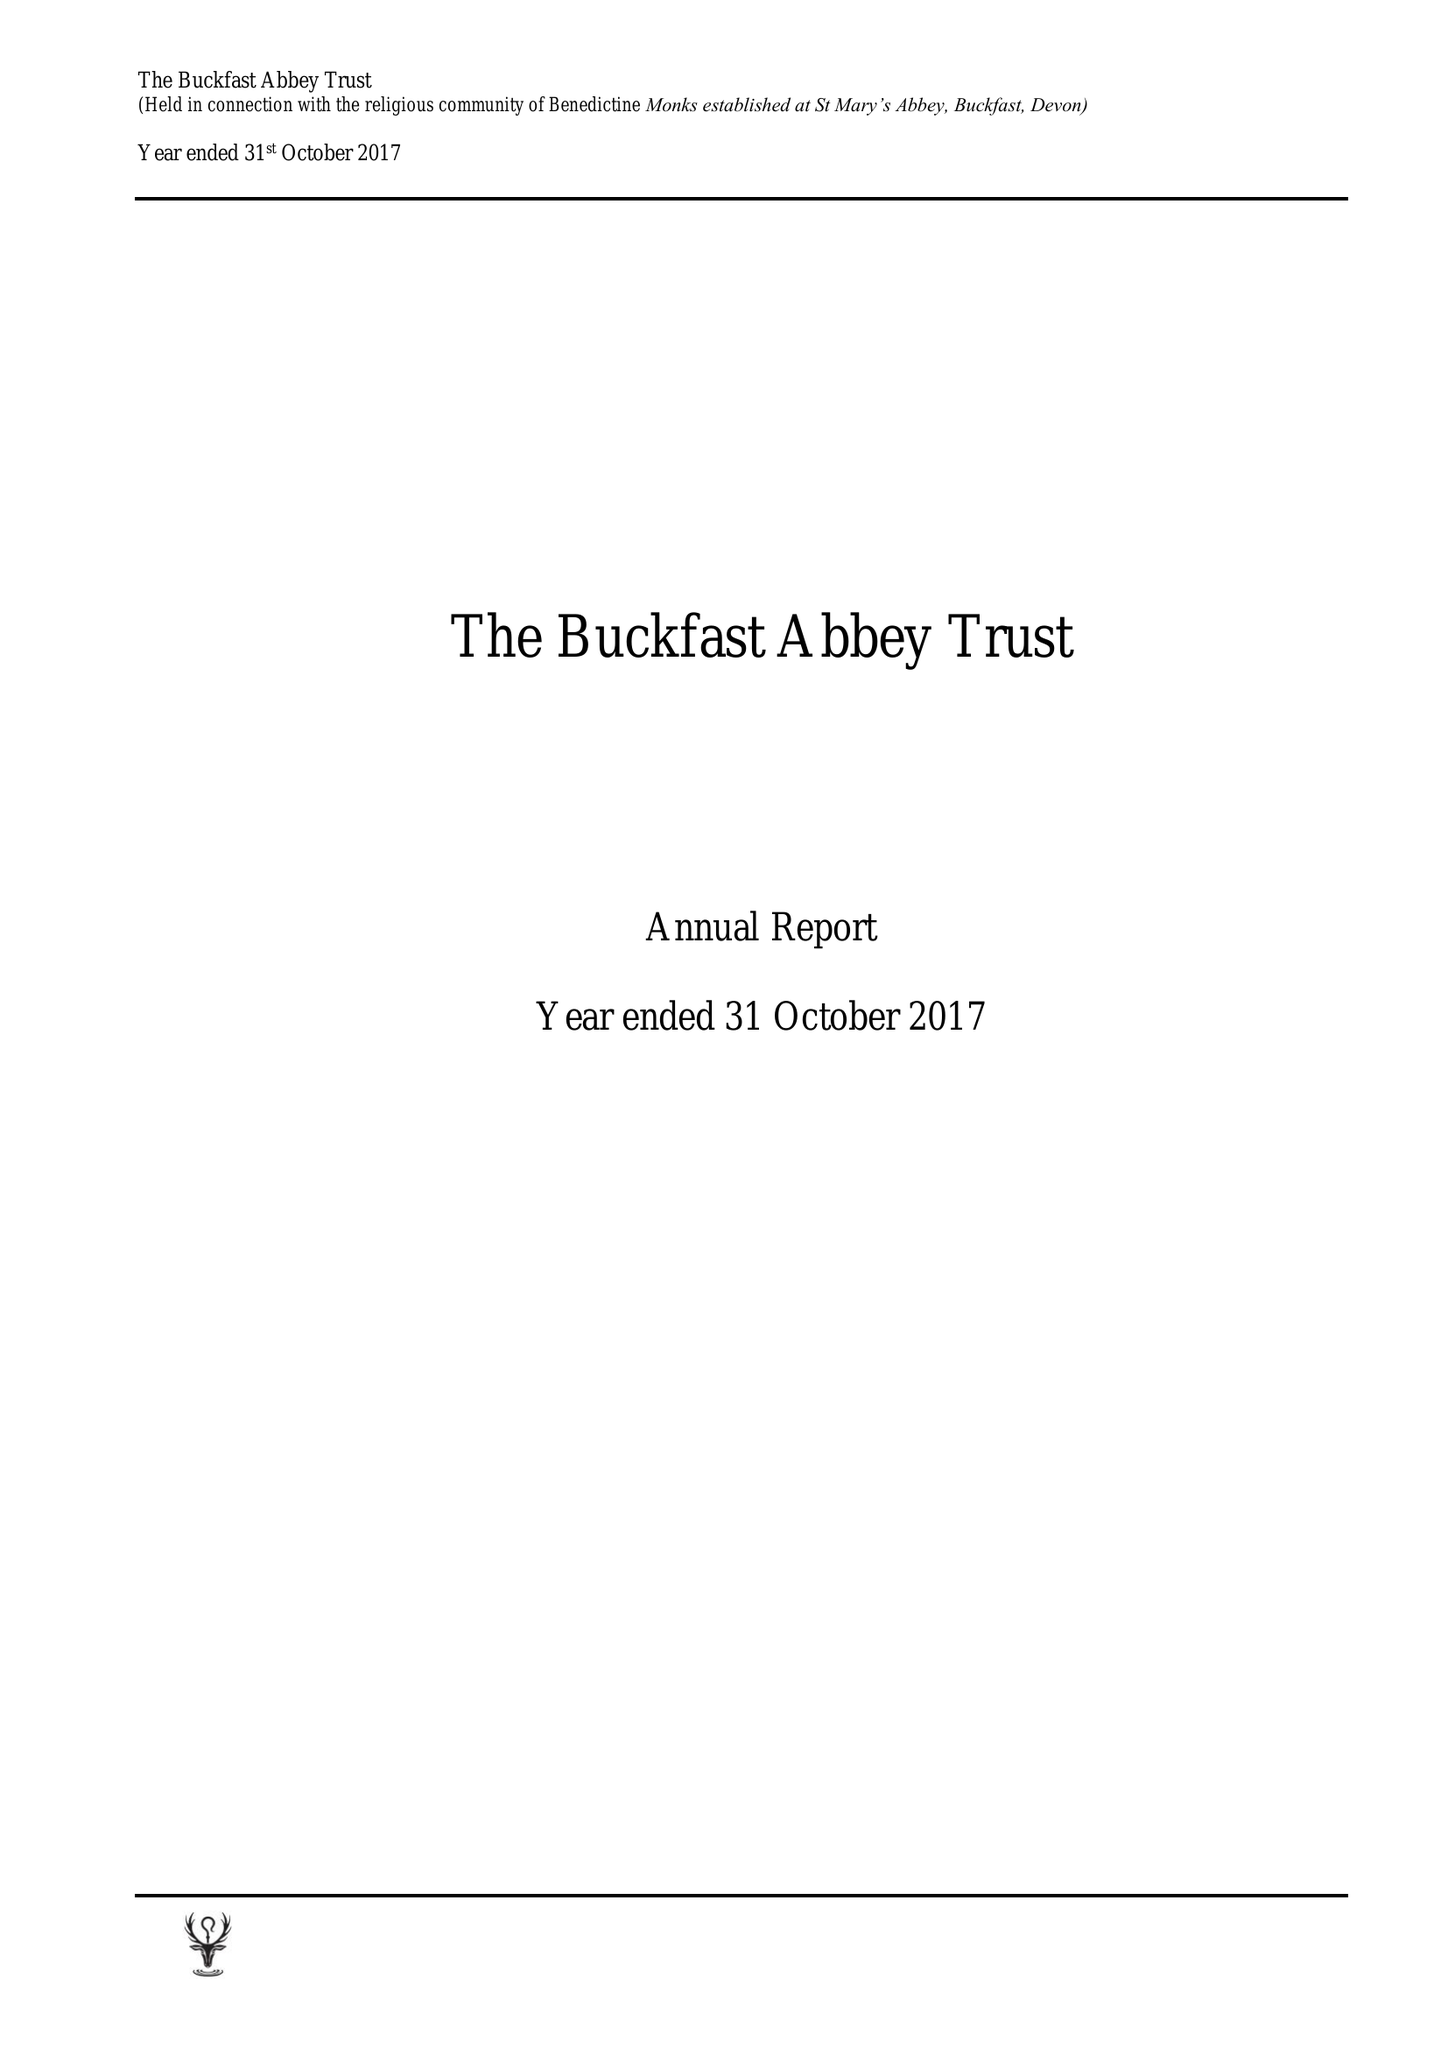What is the value for the spending_annually_in_british_pounds?
Answer the question using a single word or phrase. 8441671.00 